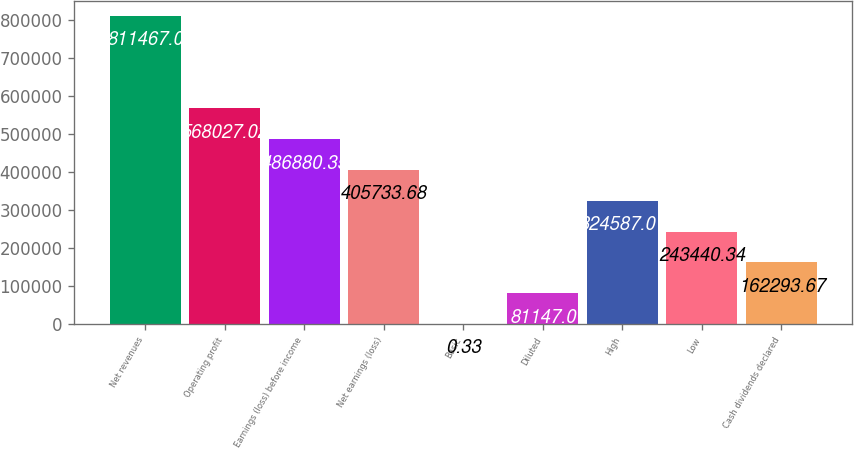Convert chart to OTSL. <chart><loc_0><loc_0><loc_500><loc_500><bar_chart><fcel>Net revenues<fcel>Operating profit<fcel>Earnings (loss) before income<fcel>Net earnings (loss)<fcel>Basic<fcel>Diluted<fcel>High<fcel>Low<fcel>Cash dividends declared<nl><fcel>811467<fcel>568027<fcel>486880<fcel>405734<fcel>0.33<fcel>81147<fcel>324587<fcel>243440<fcel>162294<nl></chart> 